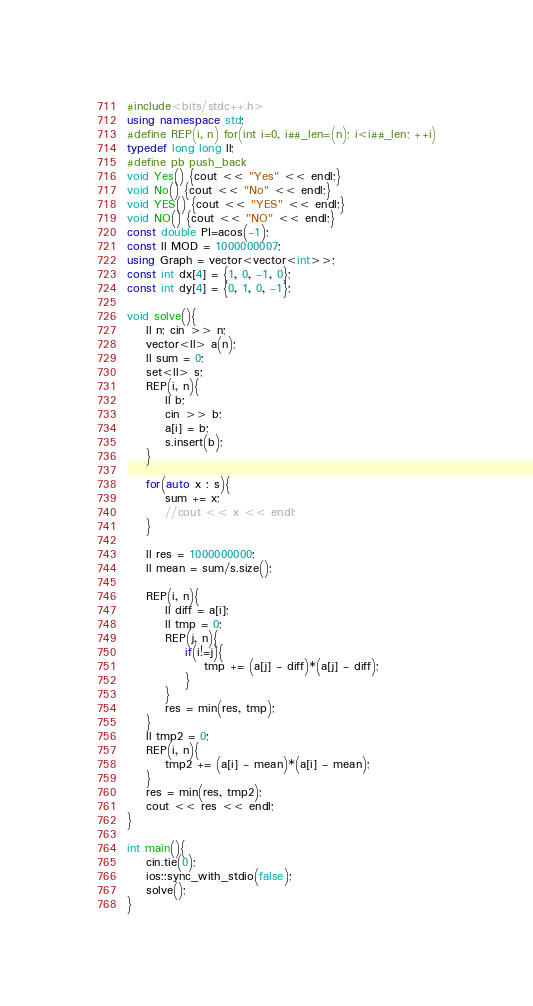Convert code to text. <code><loc_0><loc_0><loc_500><loc_500><_C++_>#include<bits/stdc++.h>
using namespace std;
#define REP(i, n) for(int i=0, i##_len=(n); i<i##_len; ++i)
typedef long long ll;
#define pb push_back
void Yes() {cout << "Yes" << endl;}
void No() {cout << "No" << endl;}
void YES() {cout << "YES" << endl;}
void NO() {cout << "NO" << endl;}
const double PI=acos(-1);
const ll MOD = 1000000007;
using Graph = vector<vector<int>>;
const int dx[4] = {1, 0, -1, 0};
const int dy[4] = {0, 1, 0, -1};

void solve(){
    ll n; cin >> n;
    vector<ll> a(n);
    ll sum = 0;
    set<ll> s;
    REP(i, n){
        ll b; 
        cin >> b;
        a[i] = b;
        s.insert(b);
    }
    
    for(auto x : s){
        sum += x;
        //cout << x << endl;
    }

    ll res = 1000000000;
    ll mean = sum/s.size();
    
    REP(i, n){
        ll diff = a[i];
        ll tmp = 0;
        REP(j, n){
            if(i!=j){
                tmp += (a[j] - diff)*(a[j] - diff);
            }
        }
        res = min(res, tmp);
    }
    ll tmp2 = 0;
    REP(i, n){
        tmp2 += (a[i] - mean)*(a[i] - mean);
    }
    res = min(res, tmp2);
    cout << res << endl;
}

int main(){
    cin.tie(0);
    ios::sync_with_stdio(false);
    solve();
}</code> 